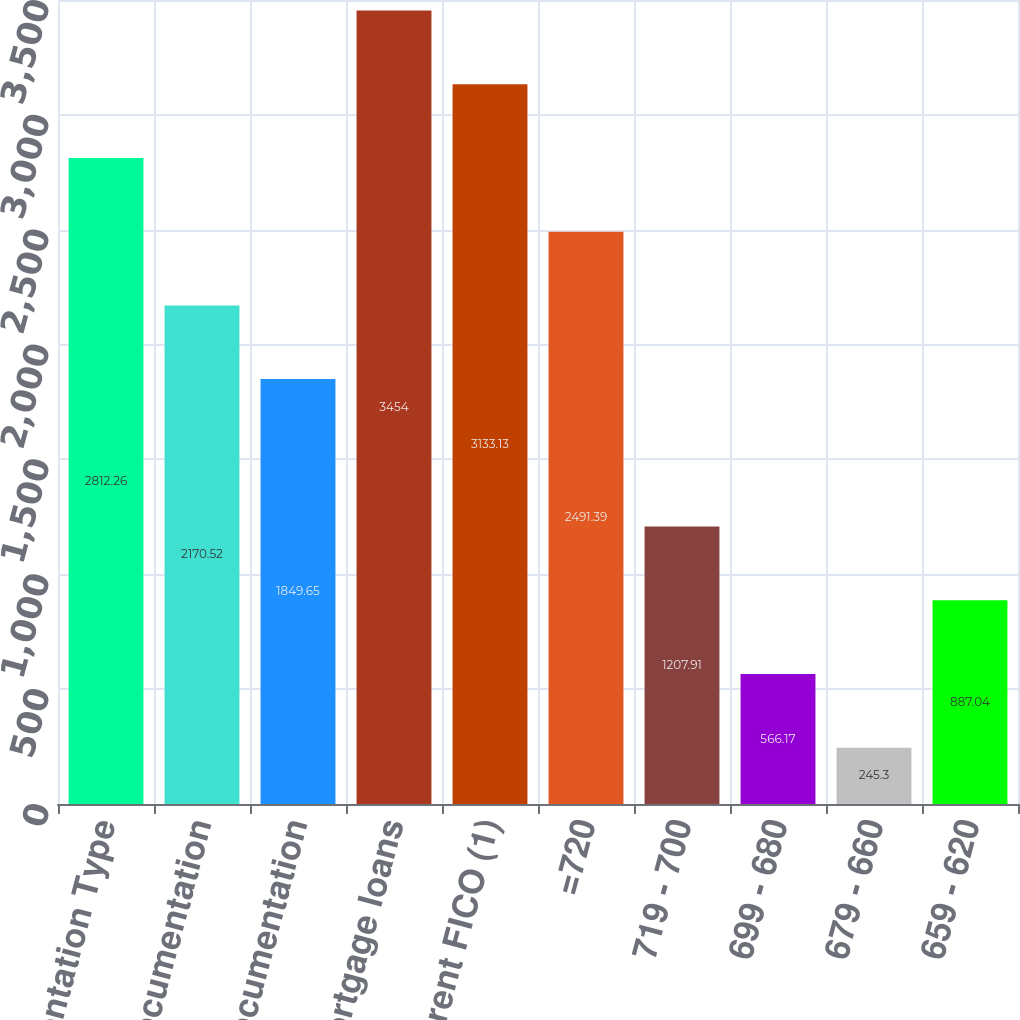Convert chart to OTSL. <chart><loc_0><loc_0><loc_500><loc_500><bar_chart><fcel>Documentation Type<fcel>Full documentation<fcel>Low/no documentation<fcel>Total mortgage loans<fcel>Current FICO (1)<fcel>=720<fcel>719 - 700<fcel>699 - 680<fcel>679 - 660<fcel>659 - 620<nl><fcel>2812.26<fcel>2170.52<fcel>1849.65<fcel>3454<fcel>3133.13<fcel>2491.39<fcel>1207.91<fcel>566.17<fcel>245.3<fcel>887.04<nl></chart> 